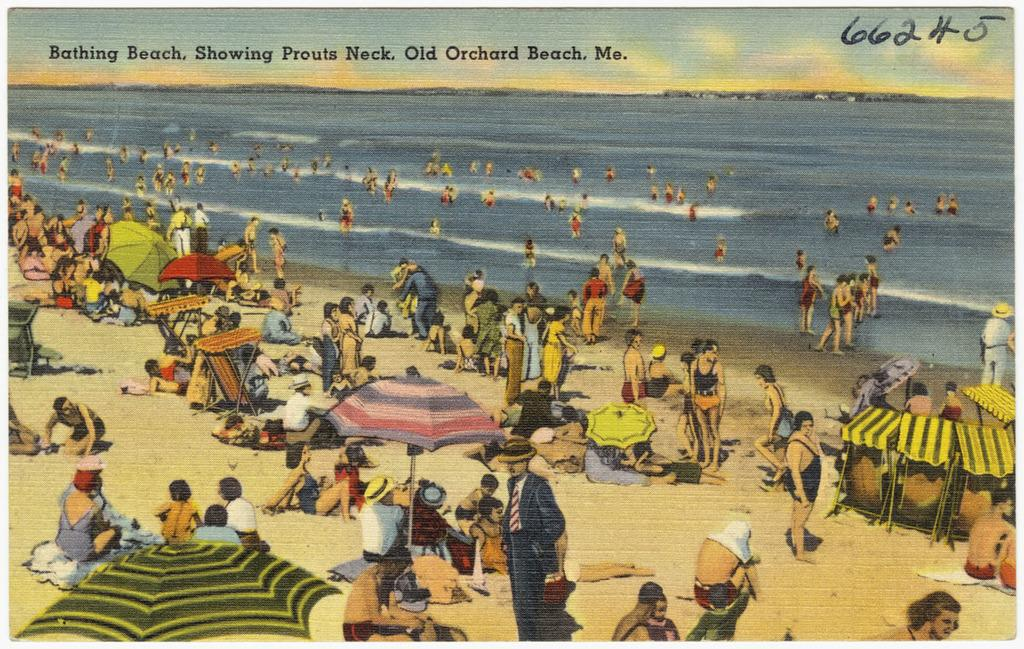<image>
Give a short and clear explanation of the subsequent image. an ocean that has the word bathing on it 